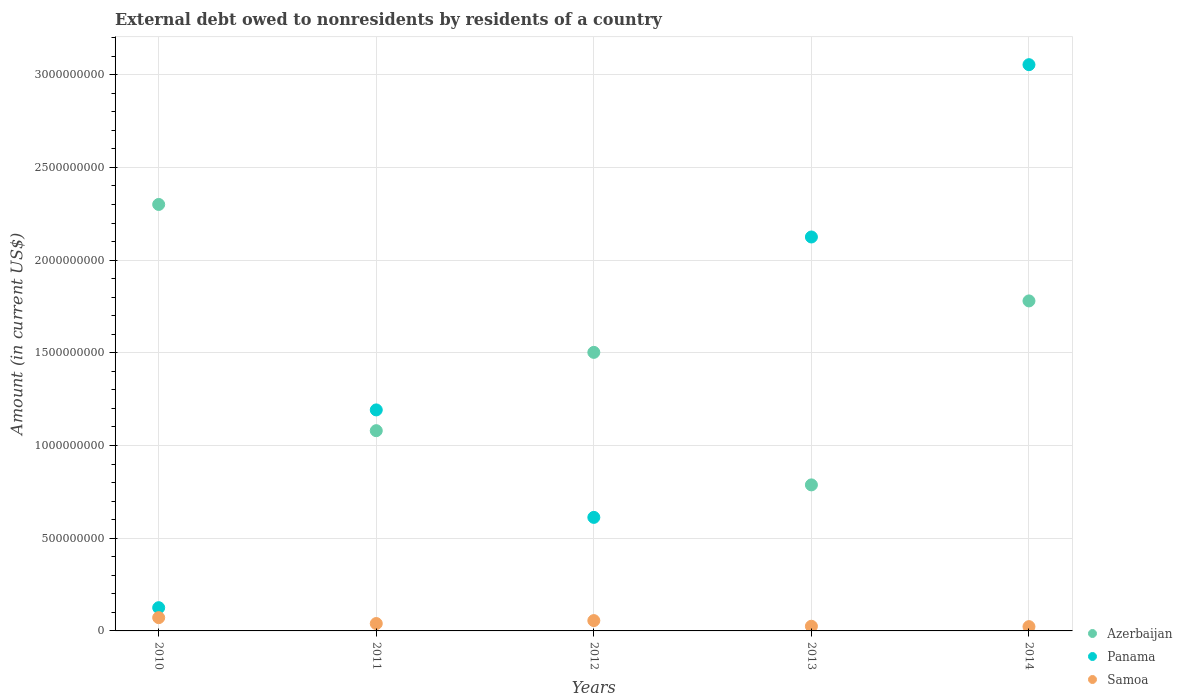How many different coloured dotlines are there?
Your response must be concise. 3. Is the number of dotlines equal to the number of legend labels?
Offer a very short reply. Yes. What is the external debt owed by residents in Azerbaijan in 2012?
Your answer should be very brief. 1.50e+09. Across all years, what is the maximum external debt owed by residents in Samoa?
Ensure brevity in your answer.  7.16e+07. Across all years, what is the minimum external debt owed by residents in Samoa?
Provide a succinct answer. 2.31e+07. In which year was the external debt owed by residents in Panama maximum?
Offer a terse response. 2014. In which year was the external debt owed by residents in Azerbaijan minimum?
Your response must be concise. 2013. What is the total external debt owed by residents in Samoa in the graph?
Ensure brevity in your answer.  2.15e+08. What is the difference between the external debt owed by residents in Samoa in 2011 and that in 2013?
Your answer should be very brief. 1.46e+07. What is the difference between the external debt owed by residents in Panama in 2014 and the external debt owed by residents in Azerbaijan in 2010?
Offer a terse response. 7.54e+08. What is the average external debt owed by residents in Panama per year?
Offer a very short reply. 1.42e+09. In the year 2010, what is the difference between the external debt owed by residents in Panama and external debt owed by residents in Samoa?
Ensure brevity in your answer.  5.37e+07. In how many years, is the external debt owed by residents in Azerbaijan greater than 900000000 US$?
Provide a succinct answer. 4. What is the ratio of the external debt owed by residents in Azerbaijan in 2010 to that in 2014?
Your answer should be very brief. 1.29. Is the external debt owed by residents in Panama in 2011 less than that in 2014?
Ensure brevity in your answer.  Yes. What is the difference between the highest and the second highest external debt owed by residents in Panama?
Make the answer very short. 9.29e+08. What is the difference between the highest and the lowest external debt owed by residents in Panama?
Offer a very short reply. 2.93e+09. In how many years, is the external debt owed by residents in Azerbaijan greater than the average external debt owed by residents in Azerbaijan taken over all years?
Give a very brief answer. 3. Is it the case that in every year, the sum of the external debt owed by residents in Azerbaijan and external debt owed by residents in Panama  is greater than the external debt owed by residents in Samoa?
Provide a succinct answer. Yes. Is the external debt owed by residents in Azerbaijan strictly greater than the external debt owed by residents in Samoa over the years?
Provide a short and direct response. Yes. Is the external debt owed by residents in Samoa strictly less than the external debt owed by residents in Panama over the years?
Make the answer very short. Yes. How many dotlines are there?
Ensure brevity in your answer.  3. What is the difference between two consecutive major ticks on the Y-axis?
Give a very brief answer. 5.00e+08. Are the values on the major ticks of Y-axis written in scientific E-notation?
Your answer should be compact. No. Does the graph contain any zero values?
Provide a succinct answer. No. Does the graph contain grids?
Provide a short and direct response. Yes. Where does the legend appear in the graph?
Your answer should be compact. Bottom right. How are the legend labels stacked?
Ensure brevity in your answer.  Vertical. What is the title of the graph?
Your response must be concise. External debt owed to nonresidents by residents of a country. Does "Burkina Faso" appear as one of the legend labels in the graph?
Keep it short and to the point. No. What is the label or title of the X-axis?
Offer a very short reply. Years. What is the label or title of the Y-axis?
Give a very brief answer. Amount (in current US$). What is the Amount (in current US$) in Azerbaijan in 2010?
Make the answer very short. 2.30e+09. What is the Amount (in current US$) of Panama in 2010?
Keep it short and to the point. 1.25e+08. What is the Amount (in current US$) in Samoa in 2010?
Make the answer very short. 7.16e+07. What is the Amount (in current US$) of Azerbaijan in 2011?
Give a very brief answer. 1.08e+09. What is the Amount (in current US$) of Panama in 2011?
Your response must be concise. 1.19e+09. What is the Amount (in current US$) in Samoa in 2011?
Make the answer very short. 3.98e+07. What is the Amount (in current US$) in Azerbaijan in 2012?
Give a very brief answer. 1.50e+09. What is the Amount (in current US$) of Panama in 2012?
Make the answer very short. 6.12e+08. What is the Amount (in current US$) in Samoa in 2012?
Your answer should be very brief. 5.57e+07. What is the Amount (in current US$) of Azerbaijan in 2013?
Your answer should be compact. 7.88e+08. What is the Amount (in current US$) in Panama in 2013?
Keep it short and to the point. 2.12e+09. What is the Amount (in current US$) in Samoa in 2013?
Offer a terse response. 2.52e+07. What is the Amount (in current US$) in Azerbaijan in 2014?
Make the answer very short. 1.78e+09. What is the Amount (in current US$) in Panama in 2014?
Offer a very short reply. 3.05e+09. What is the Amount (in current US$) of Samoa in 2014?
Your answer should be very brief. 2.31e+07. Across all years, what is the maximum Amount (in current US$) in Azerbaijan?
Ensure brevity in your answer.  2.30e+09. Across all years, what is the maximum Amount (in current US$) of Panama?
Your answer should be very brief. 3.05e+09. Across all years, what is the maximum Amount (in current US$) of Samoa?
Offer a very short reply. 7.16e+07. Across all years, what is the minimum Amount (in current US$) of Azerbaijan?
Give a very brief answer. 7.88e+08. Across all years, what is the minimum Amount (in current US$) of Panama?
Your response must be concise. 1.25e+08. Across all years, what is the minimum Amount (in current US$) in Samoa?
Give a very brief answer. 2.31e+07. What is the total Amount (in current US$) of Azerbaijan in the graph?
Your response must be concise. 7.45e+09. What is the total Amount (in current US$) in Panama in the graph?
Provide a succinct answer. 7.11e+09. What is the total Amount (in current US$) of Samoa in the graph?
Your response must be concise. 2.15e+08. What is the difference between the Amount (in current US$) of Azerbaijan in 2010 and that in 2011?
Offer a terse response. 1.22e+09. What is the difference between the Amount (in current US$) in Panama in 2010 and that in 2011?
Your response must be concise. -1.07e+09. What is the difference between the Amount (in current US$) in Samoa in 2010 and that in 2011?
Provide a succinct answer. 3.18e+07. What is the difference between the Amount (in current US$) in Azerbaijan in 2010 and that in 2012?
Give a very brief answer. 7.98e+08. What is the difference between the Amount (in current US$) of Panama in 2010 and that in 2012?
Offer a very short reply. -4.87e+08. What is the difference between the Amount (in current US$) of Samoa in 2010 and that in 2012?
Ensure brevity in your answer.  1.59e+07. What is the difference between the Amount (in current US$) in Azerbaijan in 2010 and that in 2013?
Your answer should be compact. 1.51e+09. What is the difference between the Amount (in current US$) in Panama in 2010 and that in 2013?
Your response must be concise. -2.00e+09. What is the difference between the Amount (in current US$) of Samoa in 2010 and that in 2013?
Your answer should be compact. 4.64e+07. What is the difference between the Amount (in current US$) in Azerbaijan in 2010 and that in 2014?
Offer a terse response. 5.20e+08. What is the difference between the Amount (in current US$) of Panama in 2010 and that in 2014?
Make the answer very short. -2.93e+09. What is the difference between the Amount (in current US$) in Samoa in 2010 and that in 2014?
Provide a succinct answer. 4.85e+07. What is the difference between the Amount (in current US$) of Azerbaijan in 2011 and that in 2012?
Ensure brevity in your answer.  -4.22e+08. What is the difference between the Amount (in current US$) in Panama in 2011 and that in 2012?
Ensure brevity in your answer.  5.80e+08. What is the difference between the Amount (in current US$) of Samoa in 2011 and that in 2012?
Offer a very short reply. -1.59e+07. What is the difference between the Amount (in current US$) of Azerbaijan in 2011 and that in 2013?
Provide a short and direct response. 2.92e+08. What is the difference between the Amount (in current US$) of Panama in 2011 and that in 2013?
Offer a terse response. -9.33e+08. What is the difference between the Amount (in current US$) of Samoa in 2011 and that in 2013?
Your answer should be very brief. 1.46e+07. What is the difference between the Amount (in current US$) of Azerbaijan in 2011 and that in 2014?
Provide a succinct answer. -7.00e+08. What is the difference between the Amount (in current US$) in Panama in 2011 and that in 2014?
Ensure brevity in your answer.  -1.86e+09. What is the difference between the Amount (in current US$) in Samoa in 2011 and that in 2014?
Your response must be concise. 1.67e+07. What is the difference between the Amount (in current US$) of Azerbaijan in 2012 and that in 2013?
Offer a terse response. 7.15e+08. What is the difference between the Amount (in current US$) in Panama in 2012 and that in 2013?
Offer a terse response. -1.51e+09. What is the difference between the Amount (in current US$) of Samoa in 2012 and that in 2013?
Ensure brevity in your answer.  3.05e+07. What is the difference between the Amount (in current US$) of Azerbaijan in 2012 and that in 2014?
Make the answer very short. -2.78e+08. What is the difference between the Amount (in current US$) of Panama in 2012 and that in 2014?
Keep it short and to the point. -2.44e+09. What is the difference between the Amount (in current US$) in Samoa in 2012 and that in 2014?
Your response must be concise. 3.26e+07. What is the difference between the Amount (in current US$) of Azerbaijan in 2013 and that in 2014?
Offer a terse response. -9.92e+08. What is the difference between the Amount (in current US$) of Panama in 2013 and that in 2014?
Offer a very short reply. -9.29e+08. What is the difference between the Amount (in current US$) of Samoa in 2013 and that in 2014?
Your response must be concise. 2.02e+06. What is the difference between the Amount (in current US$) in Azerbaijan in 2010 and the Amount (in current US$) in Panama in 2011?
Keep it short and to the point. 1.11e+09. What is the difference between the Amount (in current US$) in Azerbaijan in 2010 and the Amount (in current US$) in Samoa in 2011?
Keep it short and to the point. 2.26e+09. What is the difference between the Amount (in current US$) of Panama in 2010 and the Amount (in current US$) of Samoa in 2011?
Provide a succinct answer. 8.55e+07. What is the difference between the Amount (in current US$) in Azerbaijan in 2010 and the Amount (in current US$) in Panama in 2012?
Your answer should be compact. 1.69e+09. What is the difference between the Amount (in current US$) in Azerbaijan in 2010 and the Amount (in current US$) in Samoa in 2012?
Keep it short and to the point. 2.24e+09. What is the difference between the Amount (in current US$) in Panama in 2010 and the Amount (in current US$) in Samoa in 2012?
Keep it short and to the point. 6.96e+07. What is the difference between the Amount (in current US$) in Azerbaijan in 2010 and the Amount (in current US$) in Panama in 2013?
Your response must be concise. 1.75e+08. What is the difference between the Amount (in current US$) in Azerbaijan in 2010 and the Amount (in current US$) in Samoa in 2013?
Offer a very short reply. 2.28e+09. What is the difference between the Amount (in current US$) of Panama in 2010 and the Amount (in current US$) of Samoa in 2013?
Your response must be concise. 1.00e+08. What is the difference between the Amount (in current US$) in Azerbaijan in 2010 and the Amount (in current US$) in Panama in 2014?
Keep it short and to the point. -7.54e+08. What is the difference between the Amount (in current US$) in Azerbaijan in 2010 and the Amount (in current US$) in Samoa in 2014?
Provide a short and direct response. 2.28e+09. What is the difference between the Amount (in current US$) of Panama in 2010 and the Amount (in current US$) of Samoa in 2014?
Offer a very short reply. 1.02e+08. What is the difference between the Amount (in current US$) in Azerbaijan in 2011 and the Amount (in current US$) in Panama in 2012?
Offer a very short reply. 4.68e+08. What is the difference between the Amount (in current US$) in Azerbaijan in 2011 and the Amount (in current US$) in Samoa in 2012?
Make the answer very short. 1.02e+09. What is the difference between the Amount (in current US$) of Panama in 2011 and the Amount (in current US$) of Samoa in 2012?
Your response must be concise. 1.14e+09. What is the difference between the Amount (in current US$) of Azerbaijan in 2011 and the Amount (in current US$) of Panama in 2013?
Offer a terse response. -1.04e+09. What is the difference between the Amount (in current US$) in Azerbaijan in 2011 and the Amount (in current US$) in Samoa in 2013?
Your response must be concise. 1.05e+09. What is the difference between the Amount (in current US$) in Panama in 2011 and the Amount (in current US$) in Samoa in 2013?
Give a very brief answer. 1.17e+09. What is the difference between the Amount (in current US$) in Azerbaijan in 2011 and the Amount (in current US$) in Panama in 2014?
Keep it short and to the point. -1.97e+09. What is the difference between the Amount (in current US$) of Azerbaijan in 2011 and the Amount (in current US$) of Samoa in 2014?
Your answer should be compact. 1.06e+09. What is the difference between the Amount (in current US$) of Panama in 2011 and the Amount (in current US$) of Samoa in 2014?
Offer a very short reply. 1.17e+09. What is the difference between the Amount (in current US$) of Azerbaijan in 2012 and the Amount (in current US$) of Panama in 2013?
Your answer should be compact. -6.22e+08. What is the difference between the Amount (in current US$) of Azerbaijan in 2012 and the Amount (in current US$) of Samoa in 2013?
Your response must be concise. 1.48e+09. What is the difference between the Amount (in current US$) of Panama in 2012 and the Amount (in current US$) of Samoa in 2013?
Make the answer very short. 5.87e+08. What is the difference between the Amount (in current US$) of Azerbaijan in 2012 and the Amount (in current US$) of Panama in 2014?
Offer a very short reply. -1.55e+09. What is the difference between the Amount (in current US$) in Azerbaijan in 2012 and the Amount (in current US$) in Samoa in 2014?
Make the answer very short. 1.48e+09. What is the difference between the Amount (in current US$) of Panama in 2012 and the Amount (in current US$) of Samoa in 2014?
Provide a succinct answer. 5.89e+08. What is the difference between the Amount (in current US$) of Azerbaijan in 2013 and the Amount (in current US$) of Panama in 2014?
Your response must be concise. -2.27e+09. What is the difference between the Amount (in current US$) in Azerbaijan in 2013 and the Amount (in current US$) in Samoa in 2014?
Your answer should be compact. 7.65e+08. What is the difference between the Amount (in current US$) of Panama in 2013 and the Amount (in current US$) of Samoa in 2014?
Offer a very short reply. 2.10e+09. What is the average Amount (in current US$) of Azerbaijan per year?
Your answer should be compact. 1.49e+09. What is the average Amount (in current US$) of Panama per year?
Give a very brief answer. 1.42e+09. What is the average Amount (in current US$) in Samoa per year?
Your answer should be compact. 4.31e+07. In the year 2010, what is the difference between the Amount (in current US$) in Azerbaijan and Amount (in current US$) in Panama?
Provide a short and direct response. 2.17e+09. In the year 2010, what is the difference between the Amount (in current US$) of Azerbaijan and Amount (in current US$) of Samoa?
Provide a succinct answer. 2.23e+09. In the year 2010, what is the difference between the Amount (in current US$) in Panama and Amount (in current US$) in Samoa?
Keep it short and to the point. 5.37e+07. In the year 2011, what is the difference between the Amount (in current US$) of Azerbaijan and Amount (in current US$) of Panama?
Your response must be concise. -1.12e+08. In the year 2011, what is the difference between the Amount (in current US$) of Azerbaijan and Amount (in current US$) of Samoa?
Make the answer very short. 1.04e+09. In the year 2011, what is the difference between the Amount (in current US$) of Panama and Amount (in current US$) of Samoa?
Give a very brief answer. 1.15e+09. In the year 2012, what is the difference between the Amount (in current US$) in Azerbaijan and Amount (in current US$) in Panama?
Make the answer very short. 8.90e+08. In the year 2012, what is the difference between the Amount (in current US$) in Azerbaijan and Amount (in current US$) in Samoa?
Offer a terse response. 1.45e+09. In the year 2012, what is the difference between the Amount (in current US$) in Panama and Amount (in current US$) in Samoa?
Give a very brief answer. 5.57e+08. In the year 2013, what is the difference between the Amount (in current US$) in Azerbaijan and Amount (in current US$) in Panama?
Your response must be concise. -1.34e+09. In the year 2013, what is the difference between the Amount (in current US$) of Azerbaijan and Amount (in current US$) of Samoa?
Make the answer very short. 7.62e+08. In the year 2013, what is the difference between the Amount (in current US$) of Panama and Amount (in current US$) of Samoa?
Keep it short and to the point. 2.10e+09. In the year 2014, what is the difference between the Amount (in current US$) in Azerbaijan and Amount (in current US$) in Panama?
Offer a very short reply. -1.27e+09. In the year 2014, what is the difference between the Amount (in current US$) of Azerbaijan and Amount (in current US$) of Samoa?
Give a very brief answer. 1.76e+09. In the year 2014, what is the difference between the Amount (in current US$) in Panama and Amount (in current US$) in Samoa?
Give a very brief answer. 3.03e+09. What is the ratio of the Amount (in current US$) in Azerbaijan in 2010 to that in 2011?
Your response must be concise. 2.13. What is the ratio of the Amount (in current US$) of Panama in 2010 to that in 2011?
Offer a very short reply. 0.11. What is the ratio of the Amount (in current US$) of Samoa in 2010 to that in 2011?
Your answer should be compact. 1.8. What is the ratio of the Amount (in current US$) in Azerbaijan in 2010 to that in 2012?
Offer a terse response. 1.53. What is the ratio of the Amount (in current US$) of Panama in 2010 to that in 2012?
Your response must be concise. 0.2. What is the ratio of the Amount (in current US$) in Samoa in 2010 to that in 2012?
Your answer should be very brief. 1.29. What is the ratio of the Amount (in current US$) in Azerbaijan in 2010 to that in 2013?
Offer a very short reply. 2.92. What is the ratio of the Amount (in current US$) in Panama in 2010 to that in 2013?
Provide a short and direct response. 0.06. What is the ratio of the Amount (in current US$) in Samoa in 2010 to that in 2013?
Ensure brevity in your answer.  2.85. What is the ratio of the Amount (in current US$) of Azerbaijan in 2010 to that in 2014?
Offer a very short reply. 1.29. What is the ratio of the Amount (in current US$) in Panama in 2010 to that in 2014?
Your answer should be compact. 0.04. What is the ratio of the Amount (in current US$) in Samoa in 2010 to that in 2014?
Ensure brevity in your answer.  3.09. What is the ratio of the Amount (in current US$) of Azerbaijan in 2011 to that in 2012?
Ensure brevity in your answer.  0.72. What is the ratio of the Amount (in current US$) of Panama in 2011 to that in 2012?
Ensure brevity in your answer.  1.95. What is the ratio of the Amount (in current US$) in Samoa in 2011 to that in 2012?
Ensure brevity in your answer.  0.71. What is the ratio of the Amount (in current US$) in Azerbaijan in 2011 to that in 2013?
Offer a terse response. 1.37. What is the ratio of the Amount (in current US$) of Panama in 2011 to that in 2013?
Offer a terse response. 0.56. What is the ratio of the Amount (in current US$) of Samoa in 2011 to that in 2013?
Offer a terse response. 1.58. What is the ratio of the Amount (in current US$) in Azerbaijan in 2011 to that in 2014?
Offer a very short reply. 0.61. What is the ratio of the Amount (in current US$) of Panama in 2011 to that in 2014?
Give a very brief answer. 0.39. What is the ratio of the Amount (in current US$) in Samoa in 2011 to that in 2014?
Offer a terse response. 1.72. What is the ratio of the Amount (in current US$) of Azerbaijan in 2012 to that in 2013?
Provide a succinct answer. 1.91. What is the ratio of the Amount (in current US$) of Panama in 2012 to that in 2013?
Give a very brief answer. 0.29. What is the ratio of the Amount (in current US$) of Samoa in 2012 to that in 2013?
Give a very brief answer. 2.21. What is the ratio of the Amount (in current US$) in Azerbaijan in 2012 to that in 2014?
Your answer should be very brief. 0.84. What is the ratio of the Amount (in current US$) in Panama in 2012 to that in 2014?
Offer a very short reply. 0.2. What is the ratio of the Amount (in current US$) in Samoa in 2012 to that in 2014?
Make the answer very short. 2.41. What is the ratio of the Amount (in current US$) in Azerbaijan in 2013 to that in 2014?
Make the answer very short. 0.44. What is the ratio of the Amount (in current US$) of Panama in 2013 to that in 2014?
Your answer should be compact. 0.7. What is the ratio of the Amount (in current US$) of Samoa in 2013 to that in 2014?
Make the answer very short. 1.09. What is the difference between the highest and the second highest Amount (in current US$) of Azerbaijan?
Your response must be concise. 5.20e+08. What is the difference between the highest and the second highest Amount (in current US$) of Panama?
Your answer should be compact. 9.29e+08. What is the difference between the highest and the second highest Amount (in current US$) in Samoa?
Your response must be concise. 1.59e+07. What is the difference between the highest and the lowest Amount (in current US$) in Azerbaijan?
Provide a succinct answer. 1.51e+09. What is the difference between the highest and the lowest Amount (in current US$) of Panama?
Your answer should be very brief. 2.93e+09. What is the difference between the highest and the lowest Amount (in current US$) in Samoa?
Your answer should be compact. 4.85e+07. 